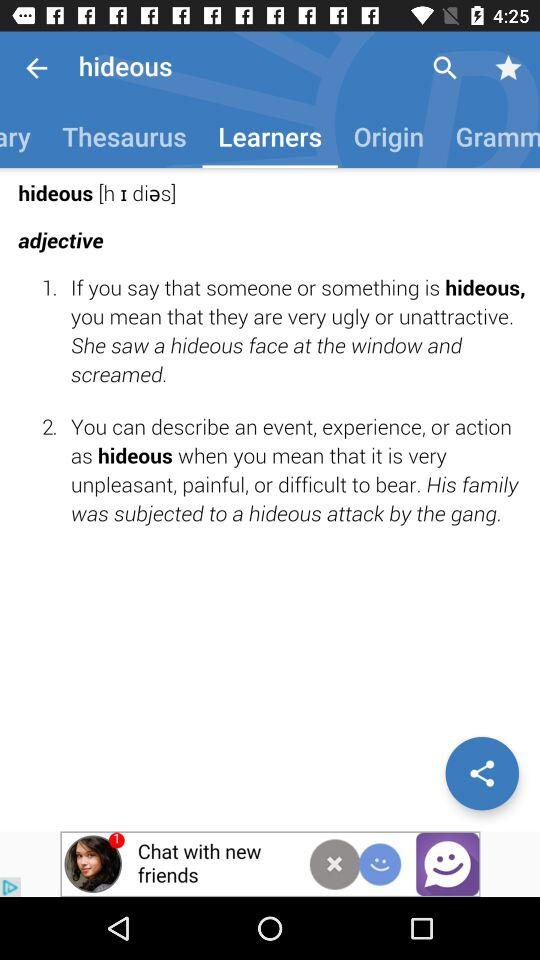What is the input text entered in the search bar? The input text entered in the search bar is hideous. 